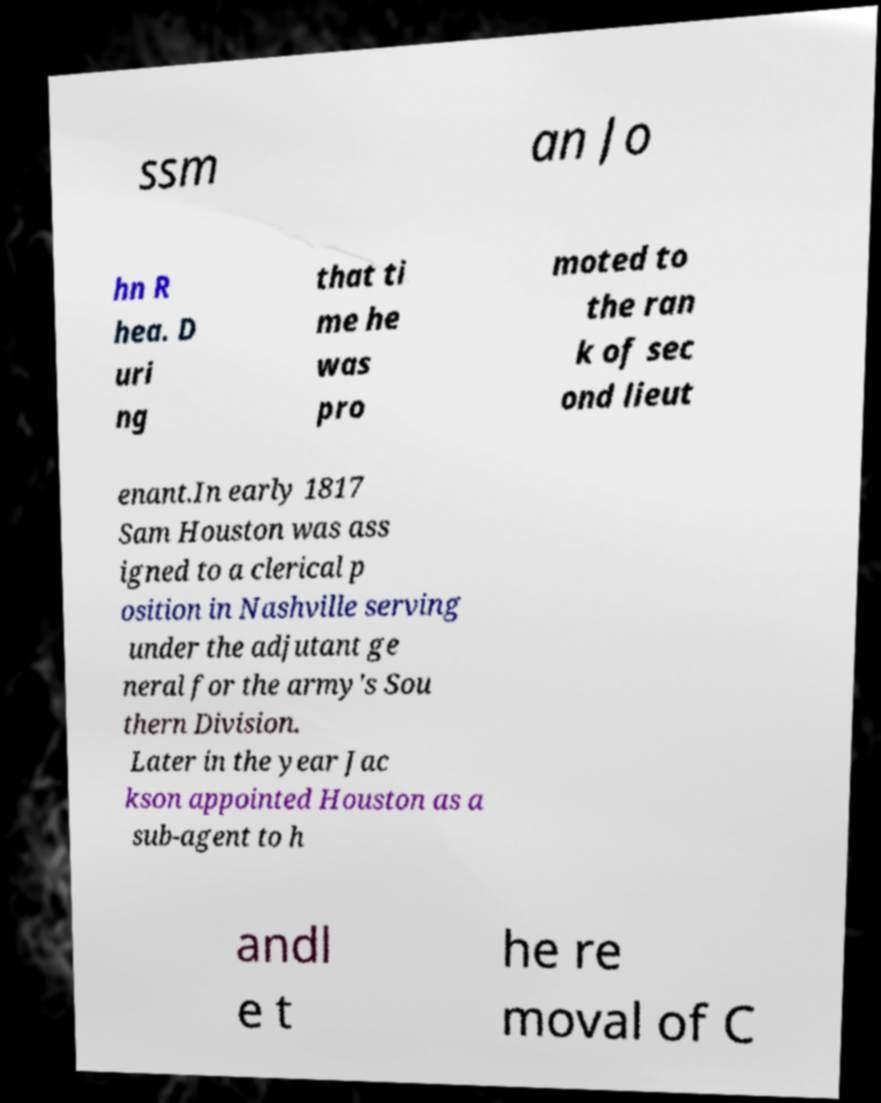What messages or text are displayed in this image? I need them in a readable, typed format. ssm an Jo hn R hea. D uri ng that ti me he was pro moted to the ran k of sec ond lieut enant.In early 1817 Sam Houston was ass igned to a clerical p osition in Nashville serving under the adjutant ge neral for the army's Sou thern Division. Later in the year Jac kson appointed Houston as a sub-agent to h andl e t he re moval of C 